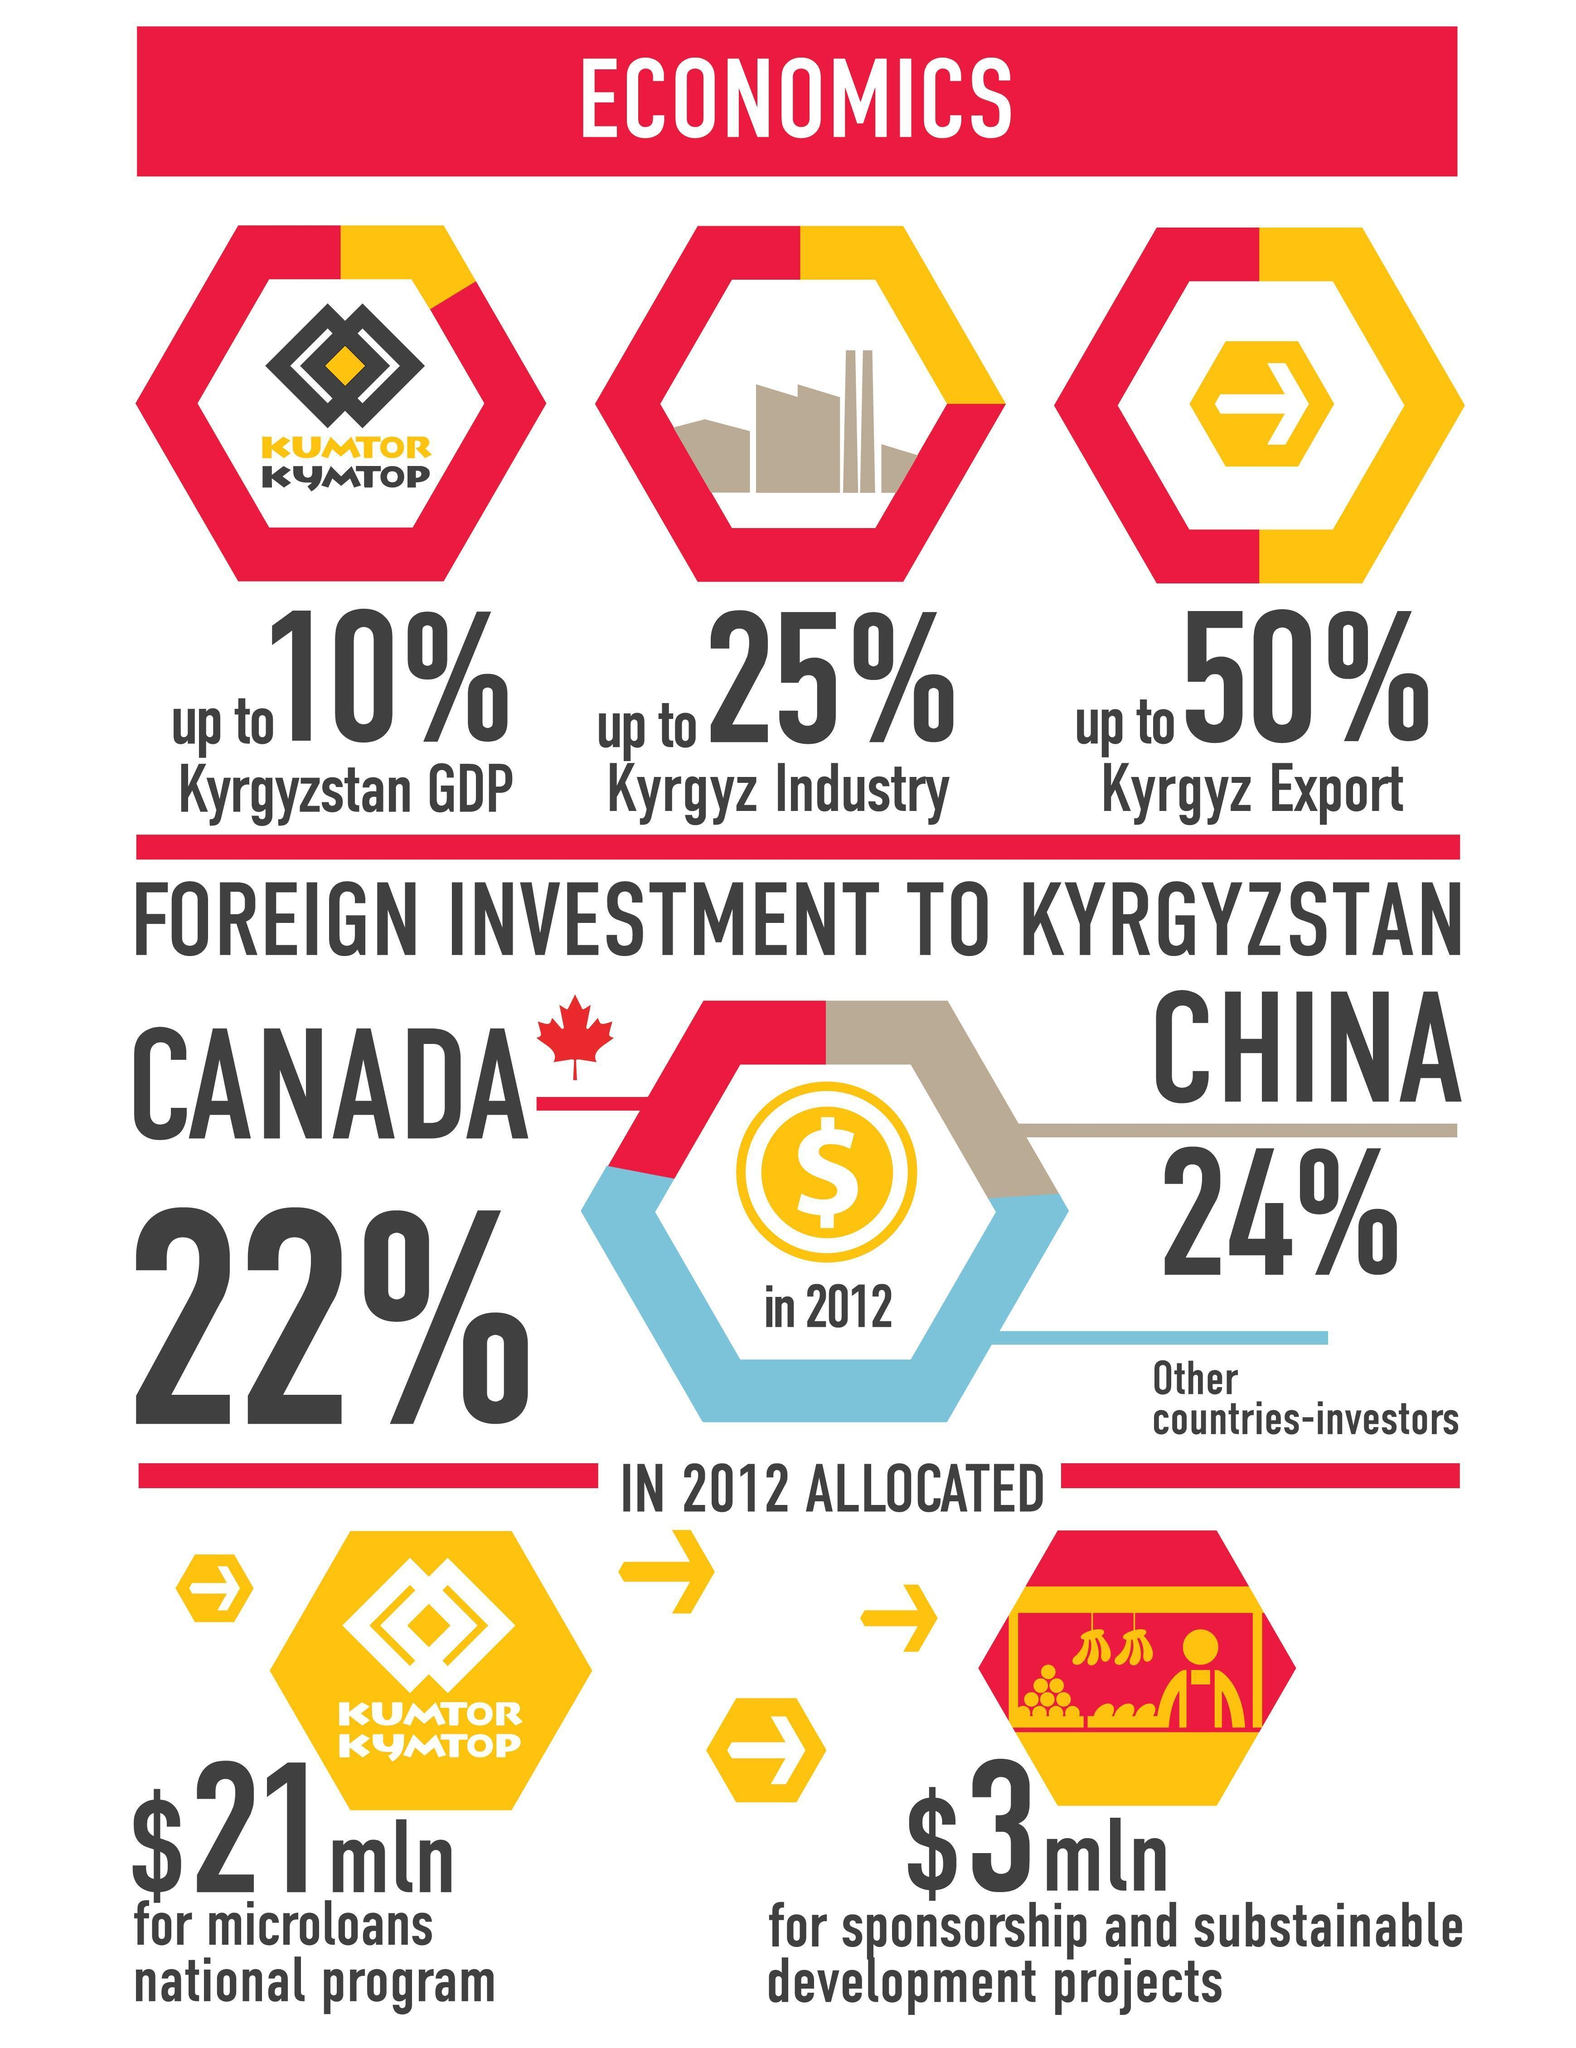What is the amount of money allocated for sponsorship and sustainable development projects in kyrgyzstan in 2012?
Answer the question with a short phrase. $3mln What percentage of foreign investment is made by Canada to kyrgyzstan in 2012? 22% What is the amount of money allocated for microloans national program in kyrgyzstan in 2012? $21mln What is the percentage of exports made in in kyrgyzstan in 2012? up to 50% What percentage of foreign investment is made by China to kyrgyzstan in 2012? 24% 